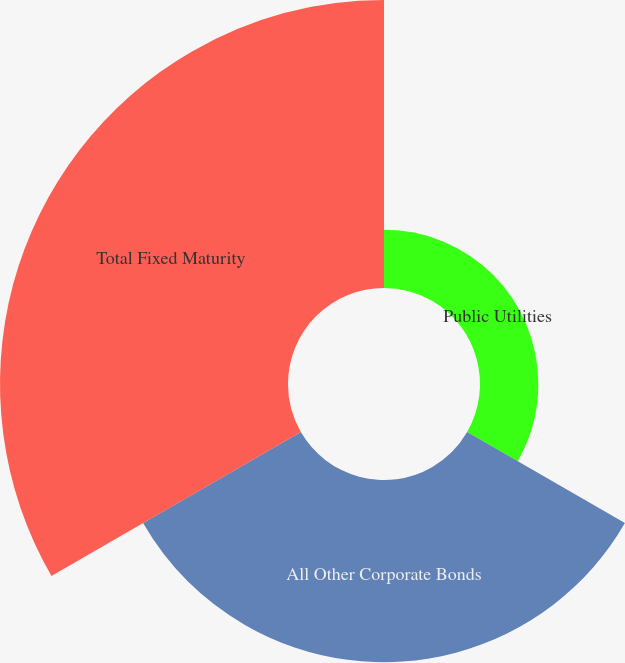<chart> <loc_0><loc_0><loc_500><loc_500><pie_chart><fcel>Public Utilities<fcel>All Other Corporate Bonds<fcel>Total Fixed Maturity<nl><fcel>11.04%<fcel>34.47%<fcel>54.49%<nl></chart> 